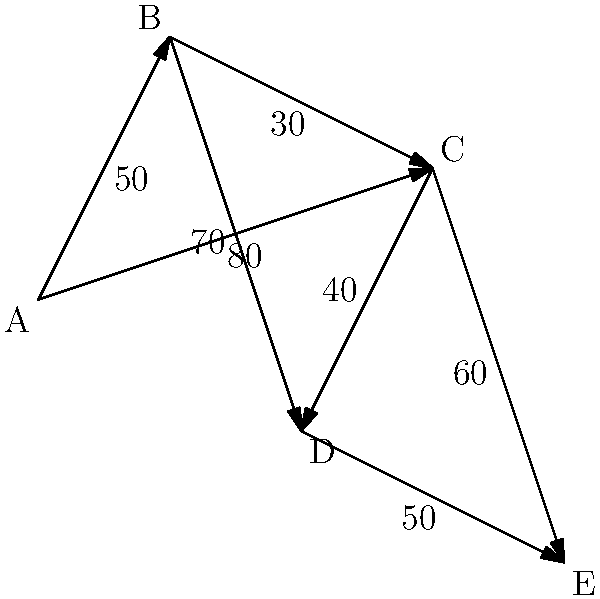As a ship captain committed to reducing carbon emissions, you need to optimize your route from port A to port E. The network diagram represents different possible routes between ports, with edge weights indicating fuel consumption in tons. What is the minimum amount of fuel required to travel from port A to port E? To find the minimum fuel consumption from port A to port E, we need to use Dijkstra's algorithm to find the shortest path:

1. Initialize:
   - Distance to A: 0
   - Distance to all other nodes: $\infty$

2. Visit A:
   - Update B: min($\infty$, 0 + 50) = 50
   - Update C: min($\infty$, 0 + 80) = 80

3. Visit B (closest unvisited node):
   - Update C: min(80, 50 + 30) = 80
   - Update D: min($\infty$, 50 + 70) = 120

4. Visit C:
   - Update D: min(120, 80 + 40) = 120
   - Update E: min($\infty$, 80 + 60) = 140

5. Visit D:
   - Update E: min(140, 120 + 50) = 140

6. Visit E (destination reached)

The shortest path is A → C → E, with a total fuel consumption of 140 tons.
Answer: 140 tons 